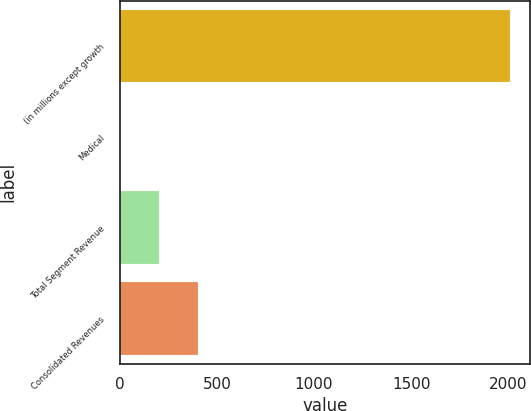Convert chart to OTSL. <chart><loc_0><loc_0><loc_500><loc_500><bar_chart><fcel>(in millions except growth<fcel>Medical<fcel>Total Segment Revenue<fcel>Consolidated Revenues<nl><fcel>2011<fcel>2<fcel>202.9<fcel>403.8<nl></chart> 